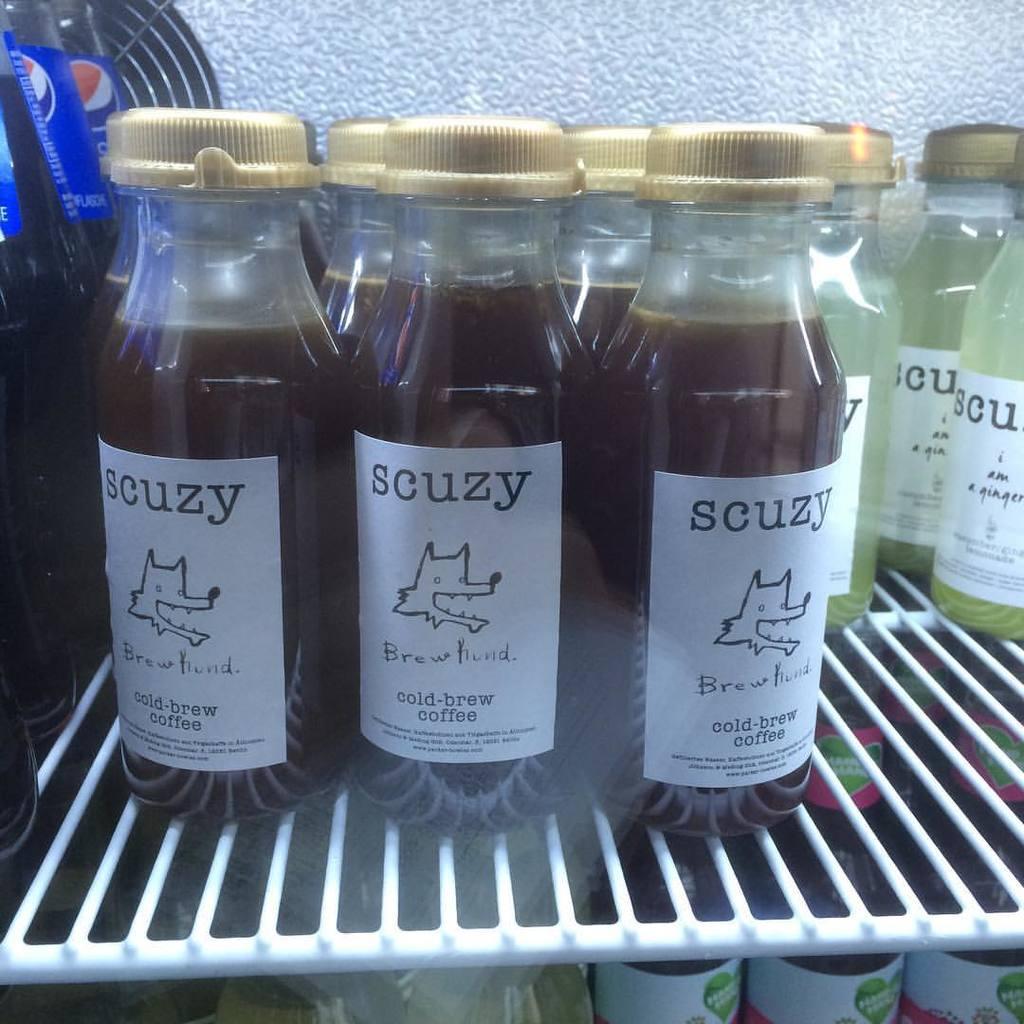Can you describe this image briefly? In this image there are so many bottles are there in the freeze. 